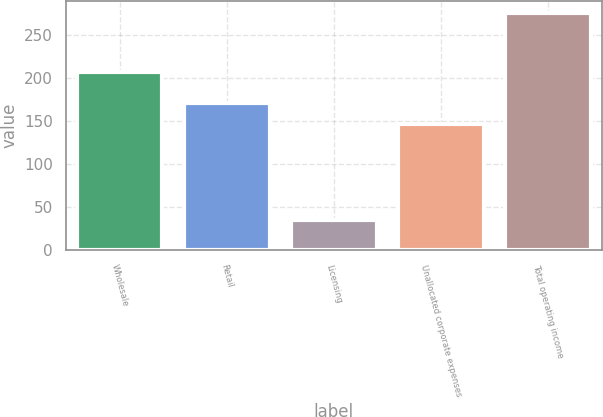Convert chart to OTSL. <chart><loc_0><loc_0><loc_500><loc_500><bar_chart><fcel>Wholesale<fcel>Retail<fcel>Licensing<fcel>Unallocated corporate expenses<fcel>Total operating income<nl><fcel>207<fcel>171.1<fcel>35<fcel>147<fcel>276<nl></chart> 